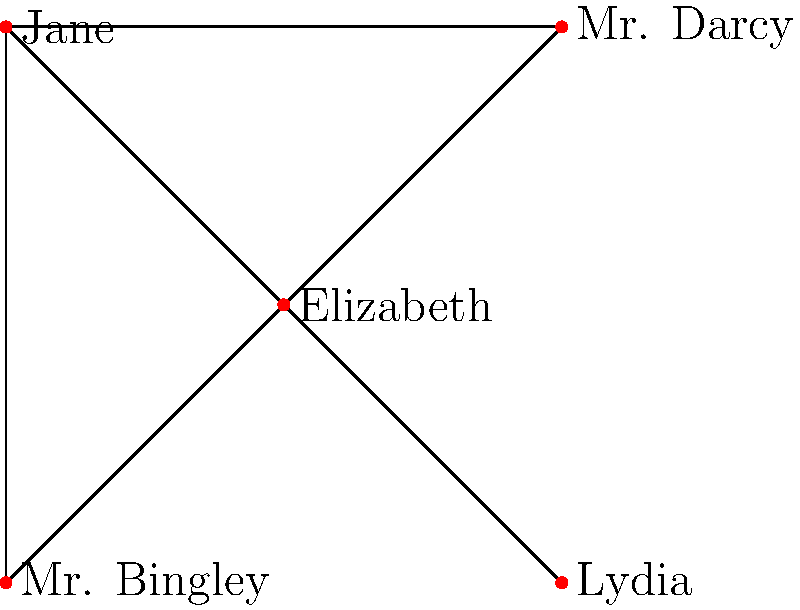In the character interaction network of Jane Austen's "Pride and Prejudice" shown above, which character has the highest degree centrality, and what does this reveal about their role in the novel? To answer this question, we need to follow these steps:

1. Understand degree centrality: In graph theory, degree centrality is the number of direct connections a node has to other nodes.

2. Count the connections for each character:
   - Elizabeth: 4 connections (to Mr. Darcy, Jane, Mr. Bingley, and Lydia)
   - Mr. Darcy: 2 connections (to Elizabeth and Jane)
   - Jane: 3 connections (to Elizabeth, Mr. Darcy, and Mr. Bingley)
   - Mr. Bingley: 2 connections (to Elizabeth and Jane)
   - Lydia: 1 connection (to Elizabeth)

3. Identify the character with the highest degree centrality:
   Elizabeth has the highest degree centrality with 4 connections.

4. Interpret the meaning in the context of the novel:
   Elizabeth's high degree centrality reflects her central role in the story. As the protagonist, she interacts with all the major characters, driving the plot forward and connecting different storylines. This aligns with her position as the main character through whose perspective much of the story is told.
Answer: Elizabeth; central protagonist connecting major characters and storylines 